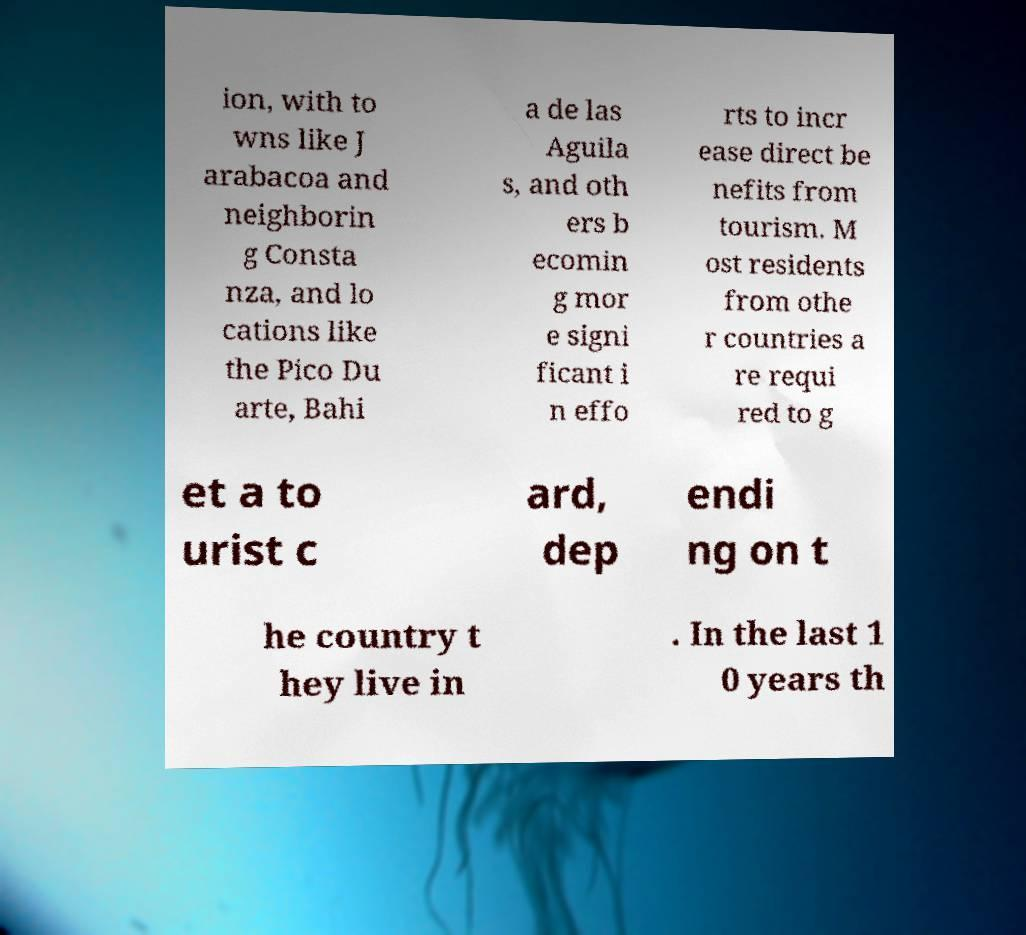Can you read and provide the text displayed in the image?This photo seems to have some interesting text. Can you extract and type it out for me? ion, with to wns like J arabacoa and neighborin g Consta nza, and lo cations like the Pico Du arte, Bahi a de las Aguila s, and oth ers b ecomin g mor e signi ficant i n effo rts to incr ease direct be nefits from tourism. M ost residents from othe r countries a re requi red to g et a to urist c ard, dep endi ng on t he country t hey live in . In the last 1 0 years th 